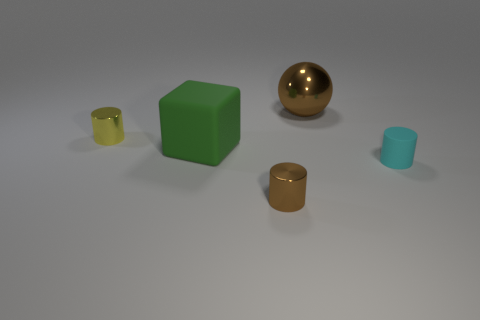Subtract all brown metallic cylinders. How many cylinders are left? 2 Add 3 yellow shiny things. How many objects exist? 8 Subtract all yellow cylinders. How many cylinders are left? 2 Subtract all spheres. How many objects are left? 4 Subtract 1 cylinders. How many cylinders are left? 2 Add 3 green objects. How many green objects are left? 4 Add 3 large green blocks. How many large green blocks exist? 4 Subtract 0 gray blocks. How many objects are left? 5 Subtract all blue cylinders. Subtract all cyan cubes. How many cylinders are left? 3 Subtract all blue balls. How many brown cylinders are left? 1 